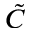<formula> <loc_0><loc_0><loc_500><loc_500>\tilde { C }</formula> 